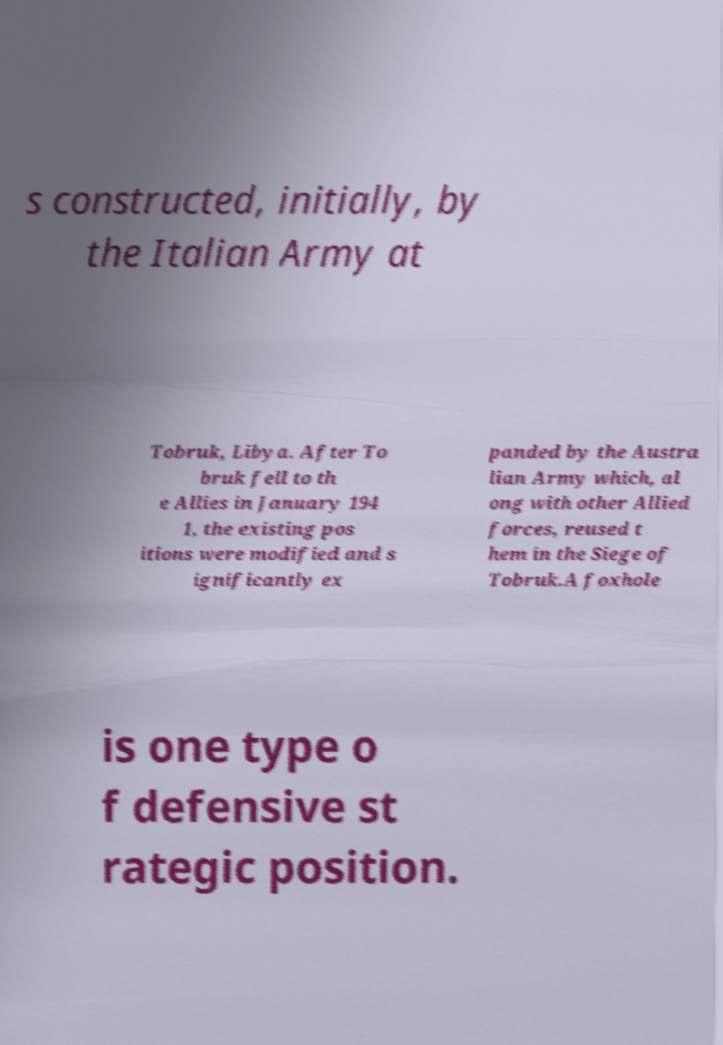Can you read and provide the text displayed in the image?This photo seems to have some interesting text. Can you extract and type it out for me? s constructed, initially, by the Italian Army at Tobruk, Libya. After To bruk fell to th e Allies in January 194 1, the existing pos itions were modified and s ignificantly ex panded by the Austra lian Army which, al ong with other Allied forces, reused t hem in the Siege of Tobruk.A foxhole is one type o f defensive st rategic position. 